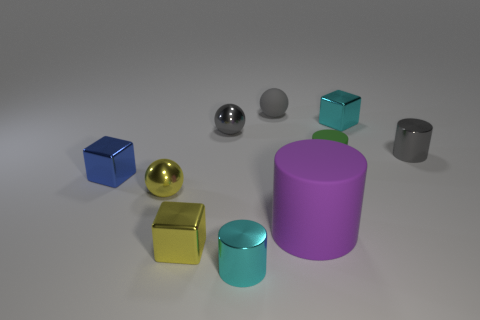Subtract 1 blocks. How many blocks are left? 2 Subtract all cyan cylinders. How many cylinders are left? 3 Subtract all tiny shiny balls. How many balls are left? 1 Subtract all brown cylinders. Subtract all brown cubes. How many cylinders are left? 4 Subtract all cylinders. How many objects are left? 6 Subtract all small gray cylinders. Subtract all small cyan blocks. How many objects are left? 8 Add 6 large purple rubber cylinders. How many large purple rubber cylinders are left? 7 Add 2 yellow objects. How many yellow objects exist? 4 Subtract 1 gray cylinders. How many objects are left? 9 